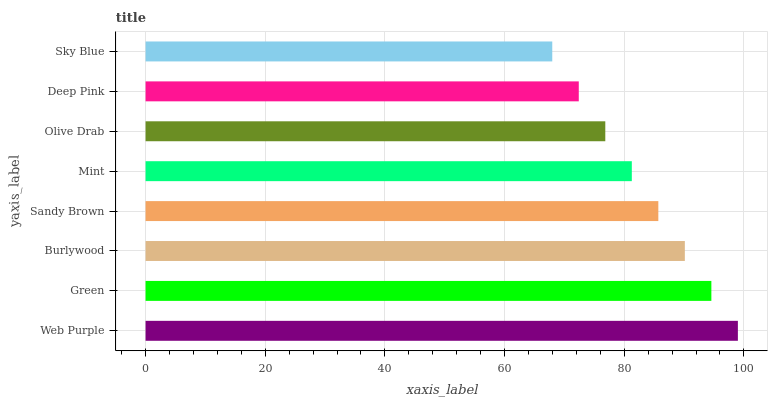Is Sky Blue the minimum?
Answer yes or no. Yes. Is Web Purple the maximum?
Answer yes or no. Yes. Is Green the minimum?
Answer yes or no. No. Is Green the maximum?
Answer yes or no. No. Is Web Purple greater than Green?
Answer yes or no. Yes. Is Green less than Web Purple?
Answer yes or no. Yes. Is Green greater than Web Purple?
Answer yes or no. No. Is Web Purple less than Green?
Answer yes or no. No. Is Sandy Brown the high median?
Answer yes or no. Yes. Is Mint the low median?
Answer yes or no. Yes. Is Mint the high median?
Answer yes or no. No. Is Burlywood the low median?
Answer yes or no. No. 